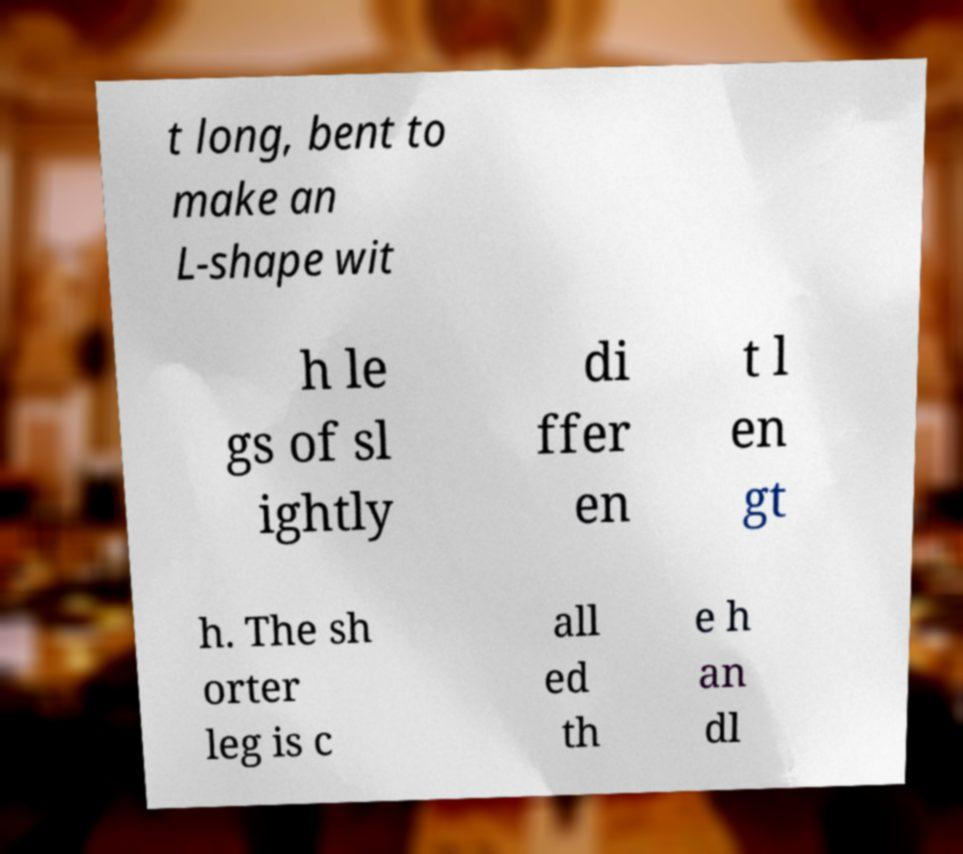There's text embedded in this image that I need extracted. Can you transcribe it verbatim? t long, bent to make an L-shape wit h le gs of sl ightly di ffer en t l en gt h. The sh orter leg is c all ed th e h an dl 